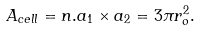<formula> <loc_0><loc_0><loc_500><loc_500>A _ { c e l l } = n . a _ { 1 } \times a _ { 2 } = 3 \pi r _ { o } ^ { 2 } .</formula> 